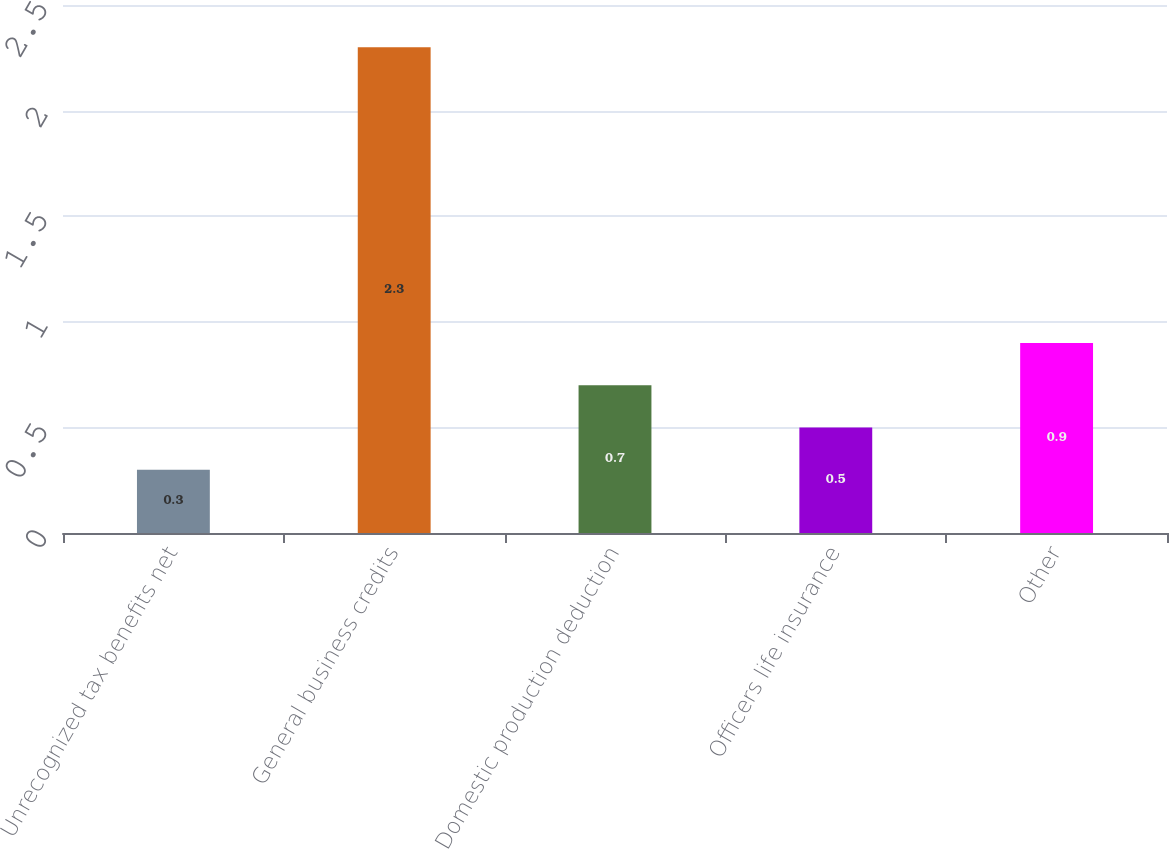Convert chart to OTSL. <chart><loc_0><loc_0><loc_500><loc_500><bar_chart><fcel>Unrecognized tax benefits net<fcel>General business credits<fcel>Domestic production deduction<fcel>Officers life insurance<fcel>Other<nl><fcel>0.3<fcel>2.3<fcel>0.7<fcel>0.5<fcel>0.9<nl></chart> 